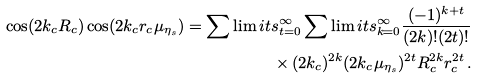<formula> <loc_0><loc_0><loc_500><loc_500>\cos ( 2 k _ { c } R _ { c } ) \cos ( 2 k _ { c } r _ { c } \mu _ { \eta _ { s } } ) = \sum \lim i t s _ { t = 0 } ^ { \infty } \sum \lim i t s _ { k = 0 } ^ { \infty } \frac { ( - 1 ) ^ { k + t } } { ( 2 k ) ! ( 2 t ) ! } \\ \times \, ( 2 k _ { c } ) ^ { 2 k } ( 2 k _ { c } \mu _ { \eta _ { s } } ) ^ { 2 t } R _ { c } ^ { 2 k } r _ { c } ^ { 2 t } \, .</formula> 